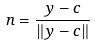Convert formula to latex. <formula><loc_0><loc_0><loc_500><loc_500>n = \frac { y - c } { \| y - c \| }</formula> 